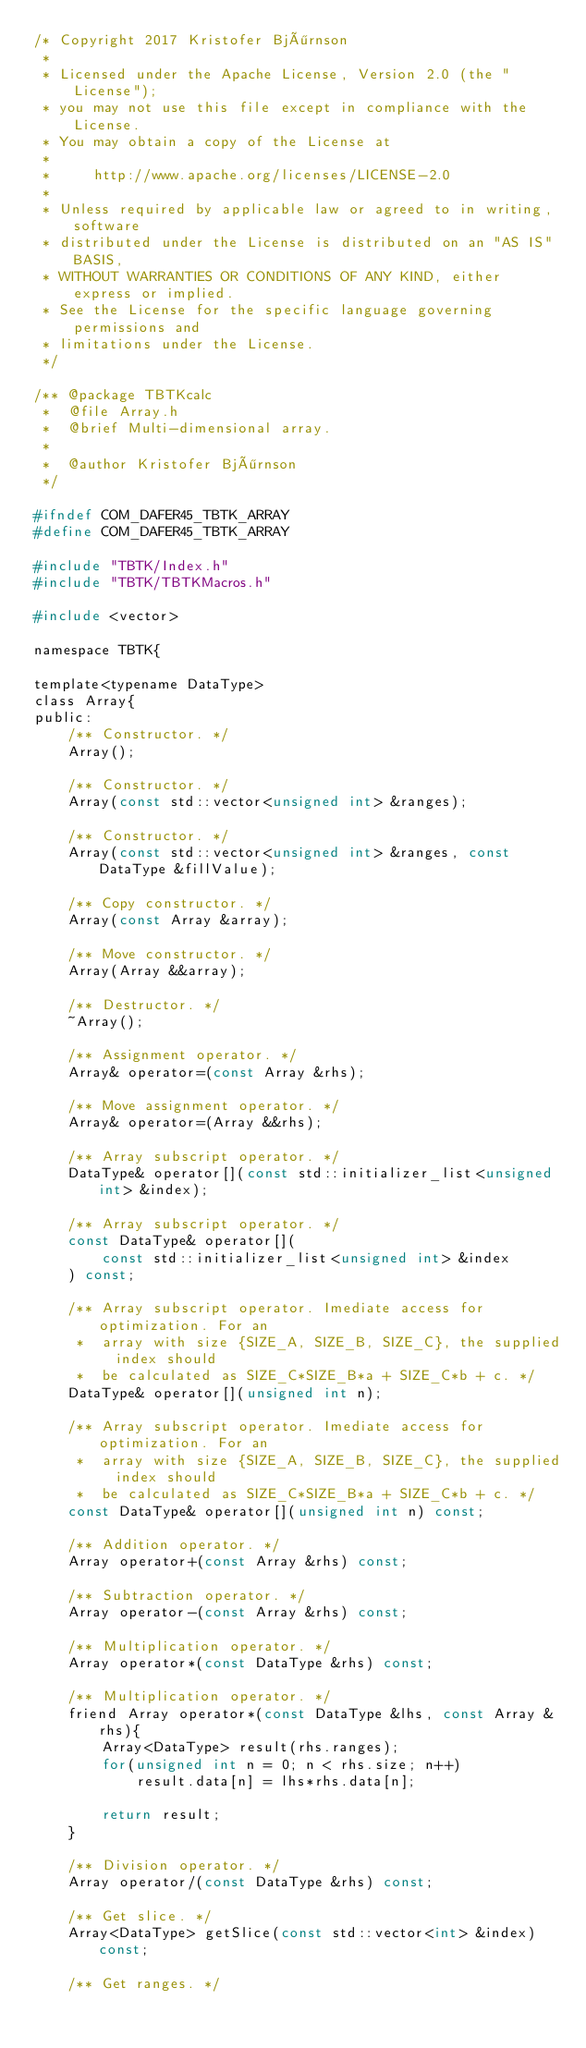Convert code to text. <code><loc_0><loc_0><loc_500><loc_500><_C_>/* Copyright 2017 Kristofer Björnson
 *
 * Licensed under the Apache License, Version 2.0 (the "License");
 * you may not use this file except in compliance with the License.
 * You may obtain a copy of the License at
 *
 *     http://www.apache.org/licenses/LICENSE-2.0
 *
 * Unless required by applicable law or agreed to in writing, software
 * distributed under the License is distributed on an "AS IS" BASIS,
 * WITHOUT WARRANTIES OR CONDITIONS OF ANY KIND, either express or implied.
 * See the License for the specific language governing permissions and
 * limitations under the License.
 */

/** @package TBTKcalc
 *  @file Array.h
 *  @brief Multi-dimensional array.
 *
 *  @author Kristofer Björnson
 */

#ifndef COM_DAFER45_TBTK_ARRAY
#define COM_DAFER45_TBTK_ARRAY

#include "TBTK/Index.h"
#include "TBTK/TBTKMacros.h"

#include <vector>

namespace TBTK{

template<typename DataType>
class Array{
public:
	/** Constructor. */
	Array();

	/** Constructor. */
	Array(const std::vector<unsigned int> &ranges);

	/** Constructor. */
	Array(const std::vector<unsigned int> &ranges, const DataType &fillValue);

	/** Copy constructor. */
	Array(const Array &array);

	/** Move constructor. */
	Array(Array &&array);

	/** Destructor. */
	~Array();

	/** Assignment operator. */
	Array& operator=(const Array &rhs);

	/** Move assignment operator. */
	Array& operator=(Array &&rhs);

	/** Array subscript operator. */
	DataType& operator[](const std::initializer_list<unsigned int> &index);

	/** Array subscript operator. */
	const DataType& operator[](
		const std::initializer_list<unsigned int> &index
	) const;

	/** Array subscript operator. Imediate access for optimization. For an
	 *  array with size {SIZE_A, SIZE_B, SIZE_C}, the supplied index should
	 *  be calculated as SIZE_C*SIZE_B*a + SIZE_C*b + c. */
	DataType& operator[](unsigned int n);

	/** Array subscript operator. Imediate access for optimization. For an
	 *  array with size {SIZE_A, SIZE_B, SIZE_C}, the supplied index should
	 *  be calculated as SIZE_C*SIZE_B*a + SIZE_C*b + c. */
	const DataType& operator[](unsigned int n) const;

	/** Addition operator. */
	Array operator+(const Array &rhs) const;

	/** Subtraction operator. */
	Array operator-(const Array &rhs) const;

	/** Multiplication operator. */
	Array operator*(const DataType &rhs) const;

	/** Multiplication operator. */
	friend Array operator*(const DataType &lhs, const Array &rhs){
		Array<DataType> result(rhs.ranges);
		for(unsigned int n = 0; n < rhs.size; n++)
			result.data[n] = lhs*rhs.data[n];

		return result;
	}

	/** Division operator. */
	Array operator/(const DataType &rhs) const;

	/** Get slice. */
	Array<DataType> getSlice(const std::vector<int> &index) const;

	/** Get ranges. */</code> 